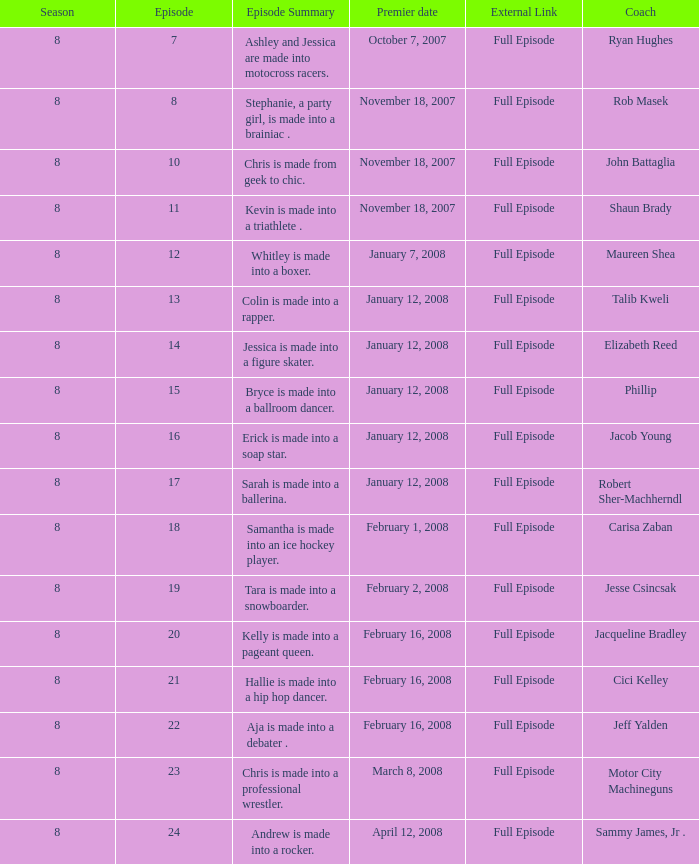What is the number of seasons with rob masek featured in them? 1.0. 